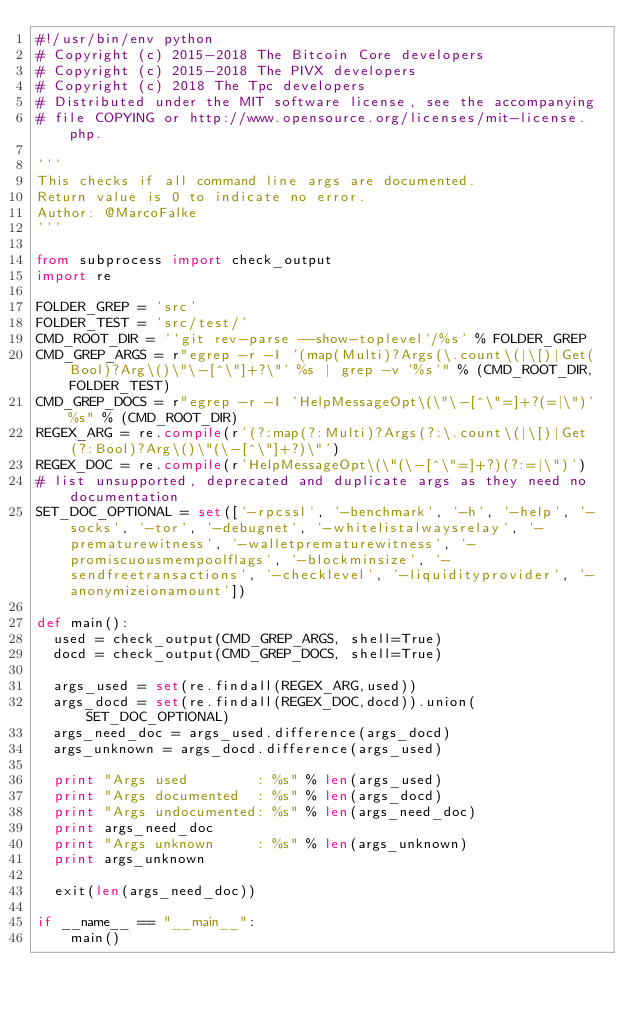<code> <loc_0><loc_0><loc_500><loc_500><_Python_>#!/usr/bin/env python
# Copyright (c) 2015-2018 The Bitcoin Core developers
# Copyright (c) 2015-2018 The PIVX developers
# Copyright (c) 2018 The Tpc developers
# Distributed under the MIT software license, see the accompanying
# file COPYING or http://www.opensource.org/licenses/mit-license.php.

'''
This checks if all command line args are documented.
Return value is 0 to indicate no error.
Author: @MarcoFalke
'''

from subprocess import check_output
import re

FOLDER_GREP = 'src'
FOLDER_TEST = 'src/test/'
CMD_ROOT_DIR = '`git rev-parse --show-toplevel`/%s' % FOLDER_GREP
CMD_GREP_ARGS = r"egrep -r -I '(map(Multi)?Args(\.count\(|\[)|Get(Bool)?Arg\()\"\-[^\"]+?\"' %s | grep -v '%s'" % (CMD_ROOT_DIR, FOLDER_TEST)
CMD_GREP_DOCS = r"egrep -r -I 'HelpMessageOpt\(\"\-[^\"=]+?(=|\")' %s" % (CMD_ROOT_DIR)
REGEX_ARG = re.compile(r'(?:map(?:Multi)?Args(?:\.count\(|\[)|Get(?:Bool)?Arg\()\"(\-[^\"]+?)\"')
REGEX_DOC = re.compile(r'HelpMessageOpt\(\"(\-[^\"=]+?)(?:=|\")')
# list unsupported, deprecated and duplicate args as they need no documentation
SET_DOC_OPTIONAL = set(['-rpcssl', '-benchmark', '-h', '-help', '-socks', '-tor', '-debugnet', '-whitelistalwaysrelay', '-prematurewitness', '-walletprematurewitness', '-promiscuousmempoolflags', '-blockminsize', '-sendfreetransactions', '-checklevel', '-liquidityprovider', '-anonymizeionamount'])

def main():
  used = check_output(CMD_GREP_ARGS, shell=True)
  docd = check_output(CMD_GREP_DOCS, shell=True)

  args_used = set(re.findall(REGEX_ARG,used))
  args_docd = set(re.findall(REGEX_DOC,docd)).union(SET_DOC_OPTIONAL)
  args_need_doc = args_used.difference(args_docd)
  args_unknown = args_docd.difference(args_used)

  print "Args used        : %s" % len(args_used)
  print "Args documented  : %s" % len(args_docd)
  print "Args undocumented: %s" % len(args_need_doc)
  print args_need_doc
  print "Args unknown     : %s" % len(args_unknown)
  print args_unknown

  exit(len(args_need_doc))

if __name__ == "__main__":
    main()
</code> 